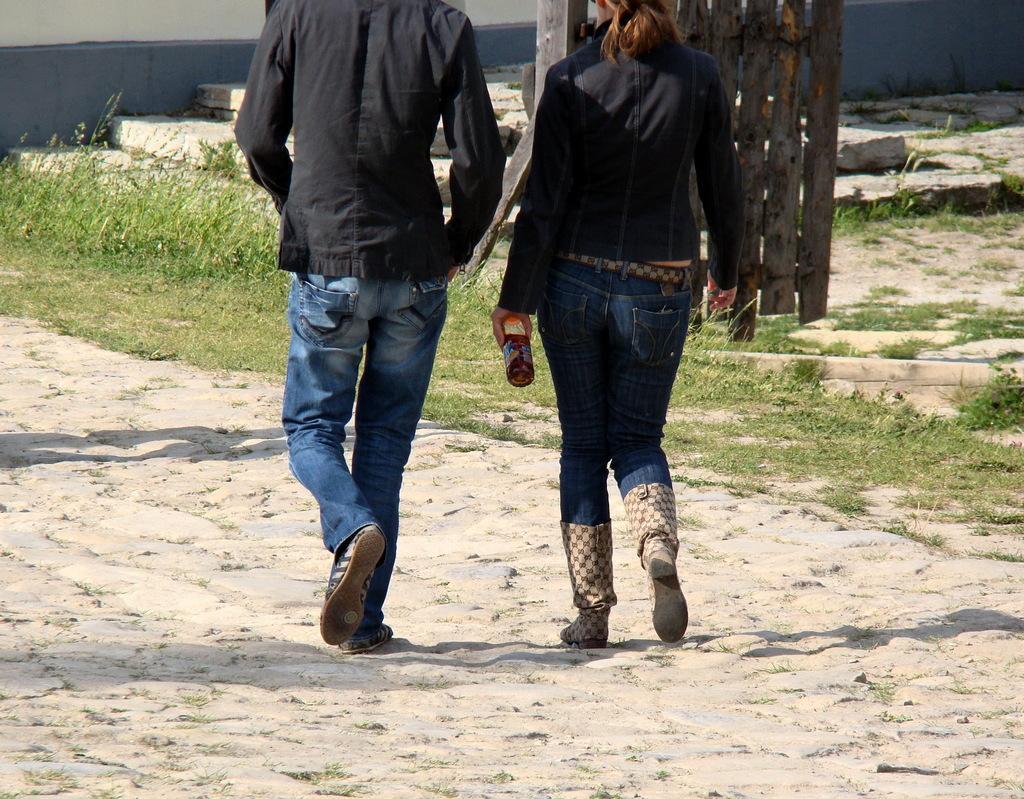In one or two sentences, can you explain what this image depicts? In this image there are two persons walking on the ground. To the right there is a woman holding a bottle in her hand. Beside them there's grass on the ground. At the background there is a wall. 